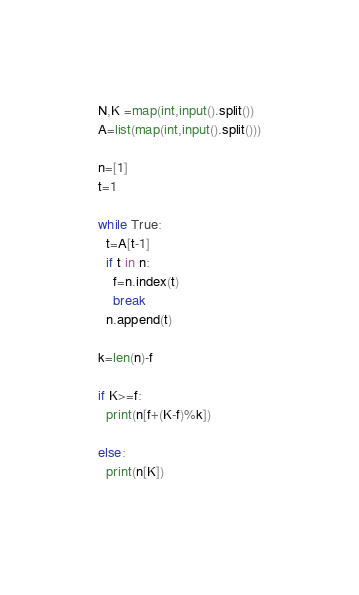<code> <loc_0><loc_0><loc_500><loc_500><_Python_>N,K =map(int,input().split())
A=list(map(int,input().split()))

n=[1]
t=1

while True:
  t=A[t-1]
  if t in n:
    f=n.index(t)
    break
  n.append(t)

k=len(n)-f

if K>=f:
  print(n[f+(K-f)%k])

else:
  print(n[K])
  
</code> 